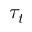<formula> <loc_0><loc_0><loc_500><loc_500>\tau _ { t }</formula> 